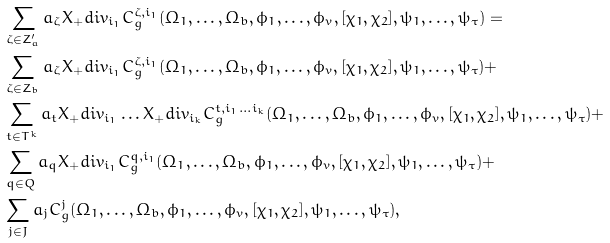Convert formula to latex. <formula><loc_0><loc_0><loc_500><loc_500>& \sum _ { \zeta \in Z ^ { \prime } _ { a } } a _ { \zeta } X _ { + } d i v _ { i _ { 1 } } C ^ { \zeta , i _ { 1 } } _ { g } ( \Omega _ { 1 } , \dots , \Omega _ { b } , \phi _ { 1 } , \dots , \phi _ { v } , [ \chi _ { 1 } , \chi _ { 2 } ] , \psi _ { 1 } , \dots , \psi _ { \tau } ) = \\ & \sum _ { \zeta \in Z _ { b } } a _ { \zeta } X _ { + } d i v _ { i _ { 1 } } C ^ { \zeta , i _ { 1 } } _ { g } ( \Omega _ { 1 } , \dots , \Omega _ { b } , \phi _ { 1 } , \dots , \phi _ { v } , [ \chi _ { 1 } , \chi _ { 2 } ] , \psi _ { 1 } , \dots , \psi _ { \tau } ) + \\ & \sum _ { t \in T ^ { k } } a _ { t } X _ { + } d i v _ { i _ { 1 } } \dots X _ { + } d i v _ { i _ { k } } C ^ { t , i _ { 1 } \dots i _ { k } } _ { g } ( \Omega _ { 1 } , \dots , \Omega _ { b } , \phi _ { 1 } , \dots , \phi _ { v } , [ \chi _ { 1 } , \chi _ { 2 } ] , \psi _ { 1 } , \dots , \psi _ { \tau } ) + \\ & \sum _ { q \in Q } a _ { q } X _ { + } d i v _ { i _ { 1 } } C ^ { q , i _ { 1 } } _ { g } ( \Omega _ { 1 } , \dots , \Omega _ { b } , \phi _ { 1 } , \dots , \phi _ { v } , [ \chi _ { 1 } , \chi _ { 2 } ] , \psi _ { 1 } , \dots , \psi _ { \tau } ) + \\ & \sum _ { j \in J } a _ { j } C ^ { j } _ { g } ( \Omega _ { 1 } , \dots , \Omega _ { b } , \phi _ { 1 } , \dots , \phi _ { v } , [ \chi _ { 1 } , \chi _ { 2 } ] , \psi _ { 1 } , \dots , \psi _ { \tau } ) ,</formula> 